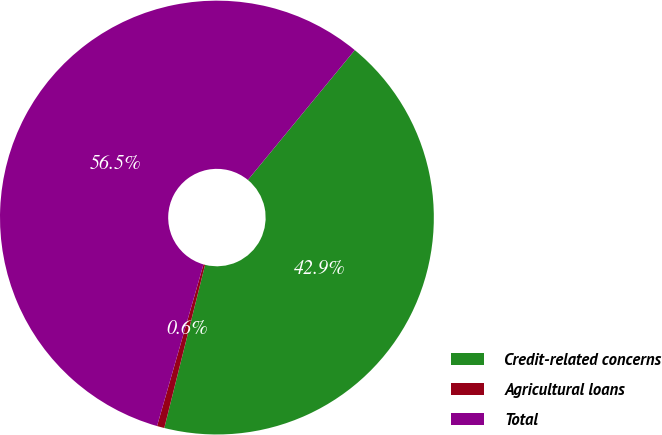Convert chart. <chart><loc_0><loc_0><loc_500><loc_500><pie_chart><fcel>Credit-related concerns<fcel>Agricultural loans<fcel>Total<nl><fcel>42.94%<fcel>0.55%<fcel>56.51%<nl></chart> 